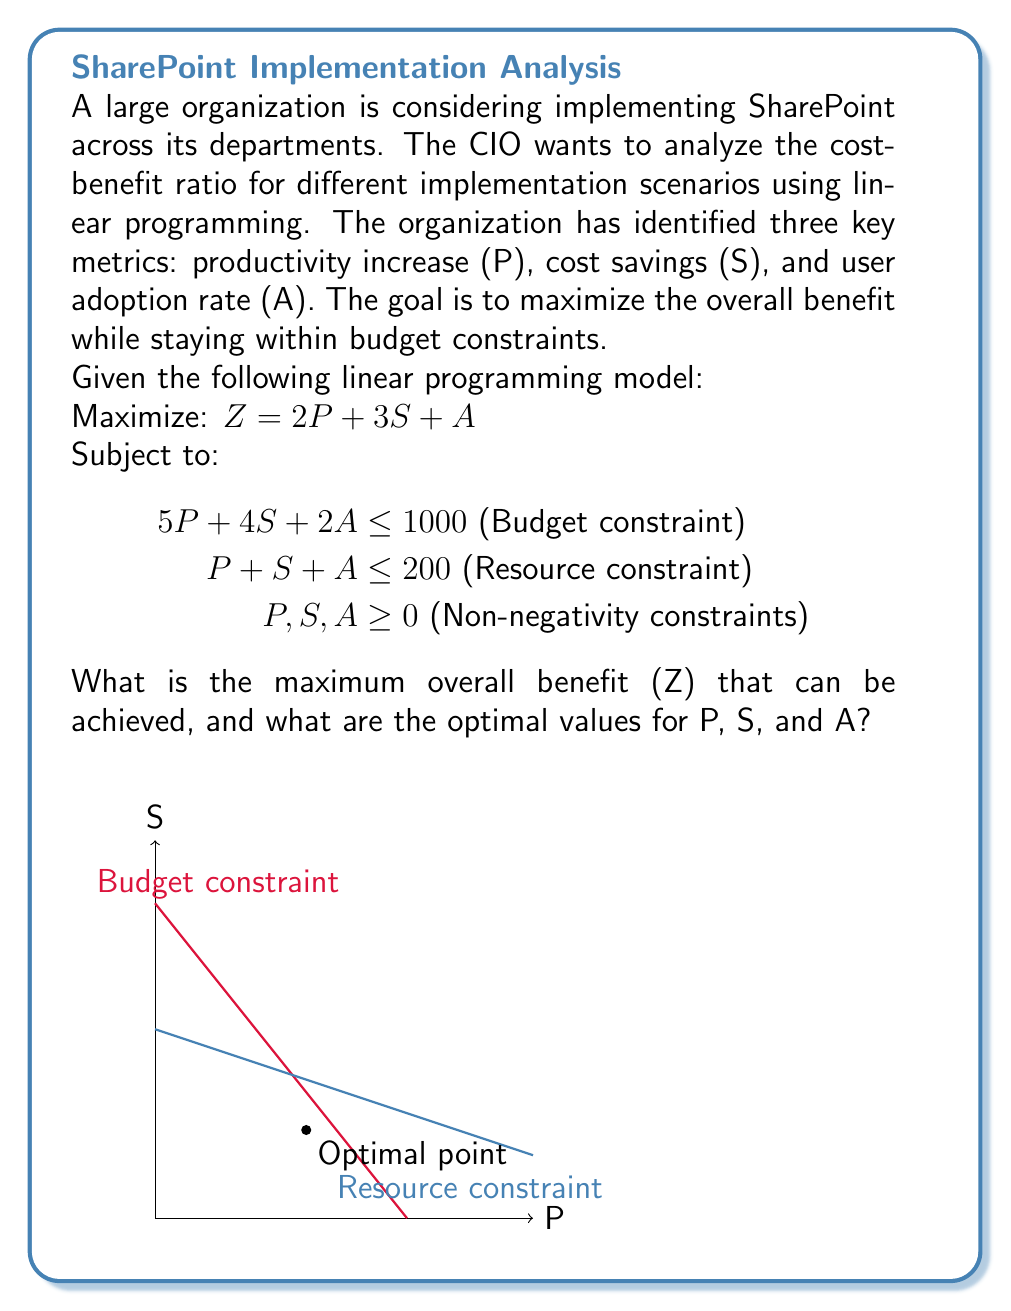What is the answer to this math problem? To solve this linear programming problem, we'll use the graphical method:

1) First, plot the constraints:
   - Budget constraint: $5P + 4S + 2A \leq 1000$
   - Resource constraint: $P + S + A \leq 200$

2) The feasible region is the area that satisfies both constraints (shown in the graph).

3) The optimal solution will be at one of the corner points of the feasible region.

4) The corner points are:
   (0, 0, 0), (200, 0, 0), (0, 200, 0), (0, 0, 500), and the intersection point of the two constraints.

5) To find the intersection point, solve:
   $$\begin{align}
   5P + 4S + 2A &= 1000 \\
   P + S + A &= 200
   \end{align}$$

   Subtracting the second equation from the first:
   $$4P + 3S + A = 800$$

   Subtracting the second equation again:
   $$3P + 2S = 600$$

   Solving this with the resource constraint:
   $$\begin{align}
   P &= 100 \\
   S &= 75 \\
   A &= 25
   \end{align}$$

6) Evaluate Z at each corner point:
   (0, 0, 0): Z = 0
   (200, 0, 0): Z = 400
   (0, 200, 0): Z = 600
   (0, 0, 500): Z = 500
   (100, 75, 25): Z = 2(100) + 3(75) + 25 = 450

7) The maximum Z value is 600, occurring at (0, 200, 0).
Answer: Maximum benefit Z = 600; Optimal values: P = 0, S = 200, A = 0 